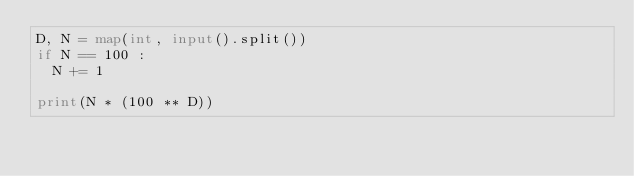<code> <loc_0><loc_0><loc_500><loc_500><_Python_>D, N = map(int, input().split())
if N == 100 :
  N += 1

print(N * (100 ** D))</code> 